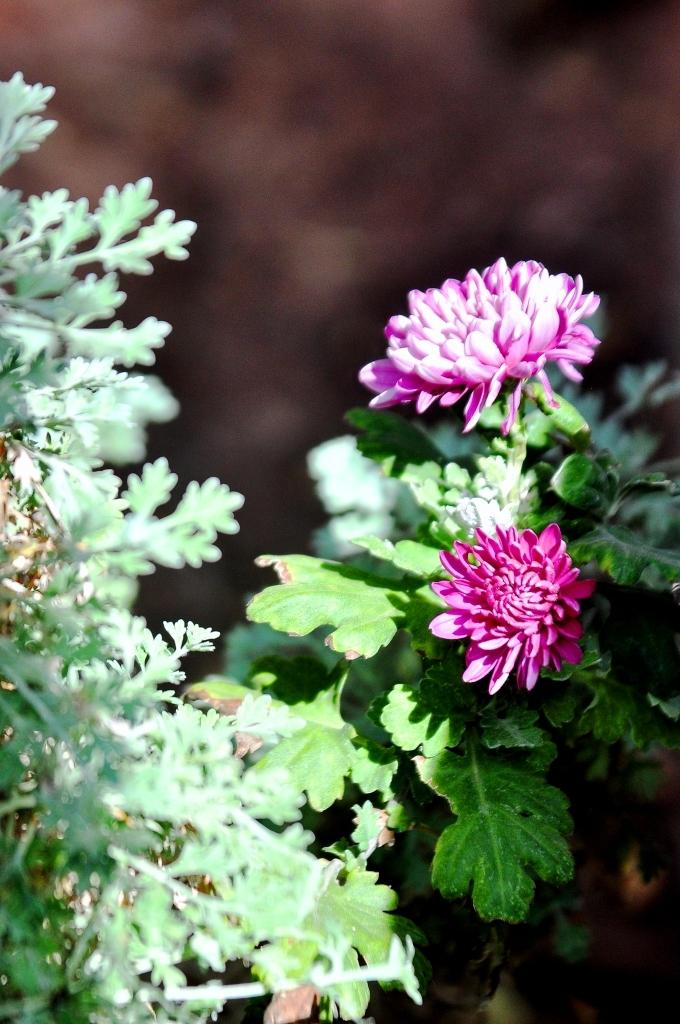What type of living organisms can be seen in the image? Plants and flowers are visible in the image. What color are the plants in the image? The plants are green in color. What colors are the flowers in the image? The flowers are pink and white in color. What colors can be seen in the background of the image? The background of the image is brown and black in color. How many mice are sitting on the knife in the image? There are no mice or knives present in the image. What type of flame can be seen in the image? There is no flame present in the image. 